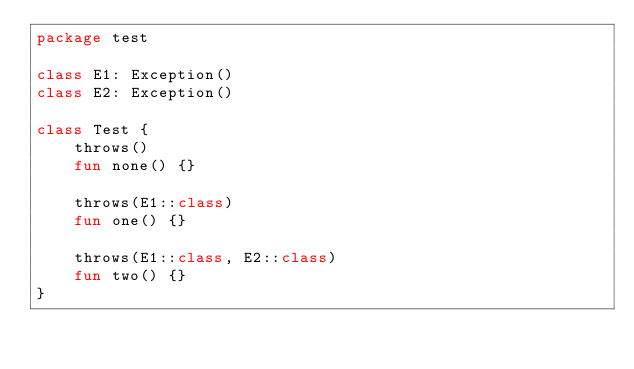<code> <loc_0><loc_0><loc_500><loc_500><_Kotlin_>package test

class E1: Exception()
class E2: Exception()

class Test {
    throws()
    fun none() {}

    throws(E1::class)
    fun one() {}

    throws(E1::class, E2::class)
    fun two() {}
}</code> 